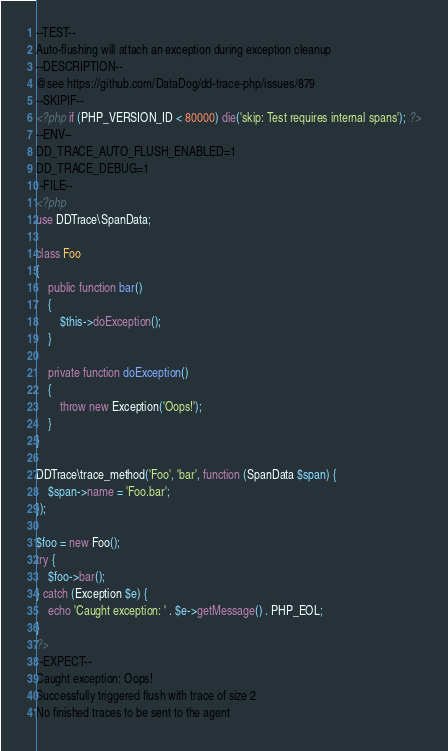Convert code to text. <code><loc_0><loc_0><loc_500><loc_500><_PHP_>--TEST--
Auto-flushing will attach an exception during exception cleanup
--DESCRIPTION--
@see https://github.com/DataDog/dd-trace-php/issues/879
--SKIPIF--
<?php if (PHP_VERSION_ID < 80000) die('skip: Test requires internal spans'); ?>
--ENV--
DD_TRACE_AUTO_FLUSH_ENABLED=1
DD_TRACE_DEBUG=1
--FILE--
<?php
use DDTrace\SpanData;

class Foo
{
    public function bar()
    {
        $this->doException();
    }

    private function doException()
    {
        throw new Exception('Oops!');
    }
}

DDTrace\trace_method('Foo', 'bar', function (SpanData $span) {
    $span->name = 'Foo.bar';
});

$foo = new Foo();
try {
    $foo->bar();
} catch (Exception $e) {
    echo 'Caught exception: ' . $e->getMessage() . PHP_EOL;
}
?>
--EXPECT--
Caught exception: Oops!
Successfully triggered flush with trace of size 2
No finished traces to be sent to the agent
</code> 